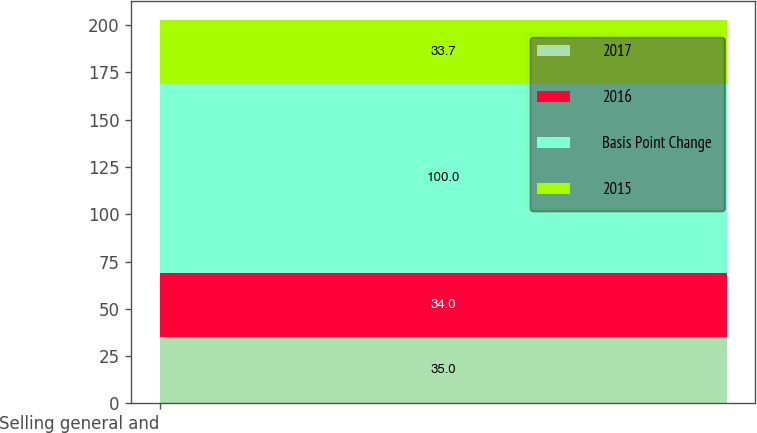<chart> <loc_0><loc_0><loc_500><loc_500><stacked_bar_chart><ecel><fcel>Selling general and<nl><fcel>2017<fcel>35<nl><fcel>2016<fcel>34<nl><fcel>Basis Point Change<fcel>100<nl><fcel>2015<fcel>33.7<nl></chart> 